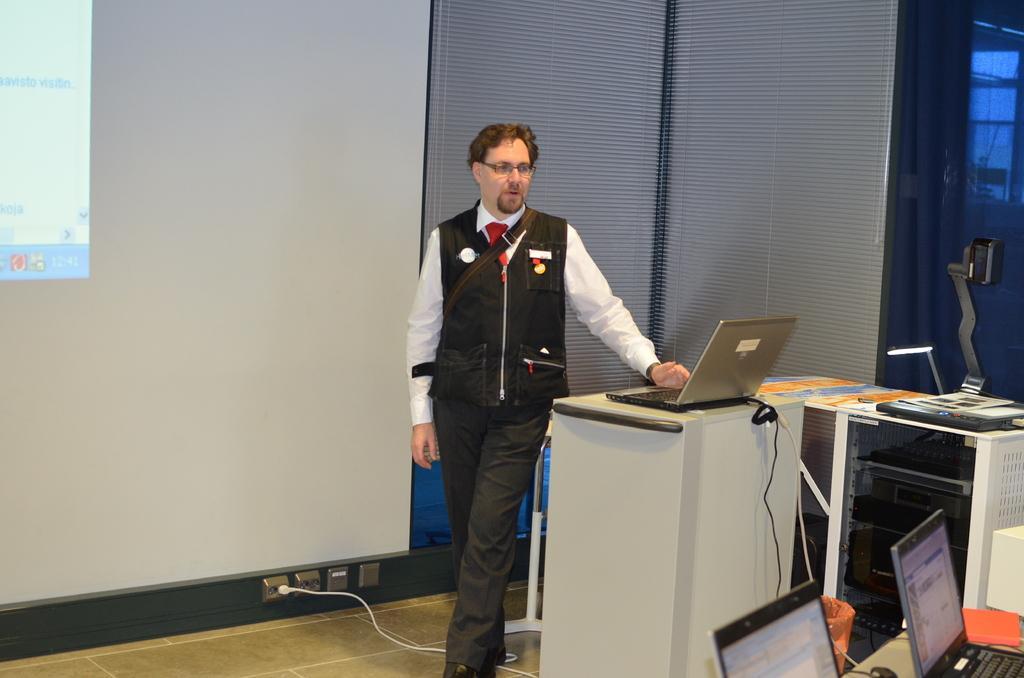Could you give a brief overview of what you see in this image? In the middle of this image, there is a person in black color jacket, speaking and placing a hand on a stand, on which there is a laptop. On the left side, there is a screen. On the right side, there are laptops on a table. In the background, there is a table, on which there are some objects and there is a blue color wall. 